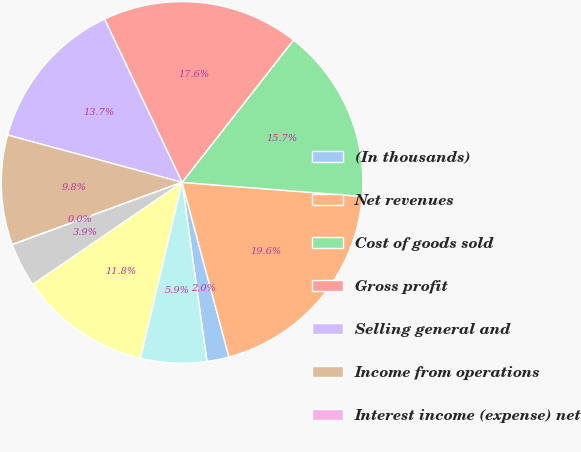Convert chart. <chart><loc_0><loc_0><loc_500><loc_500><pie_chart><fcel>(In thousands)<fcel>Net revenues<fcel>Cost of goods sold<fcel>Gross profit<fcel>Selling general and<fcel>Income from operations<fcel>Interest income (expense) net<fcel>Other income (expense) net<fcel>Income before income taxes<fcel>Provision for income taxes<nl><fcel>1.98%<fcel>19.58%<fcel>15.67%<fcel>17.63%<fcel>13.72%<fcel>9.8%<fcel>0.02%<fcel>3.94%<fcel>11.76%<fcel>5.89%<nl></chart> 